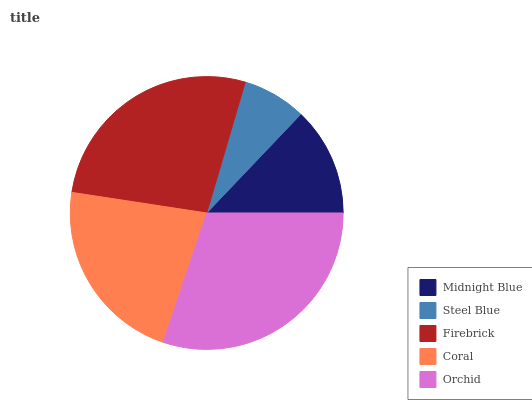Is Steel Blue the minimum?
Answer yes or no. Yes. Is Orchid the maximum?
Answer yes or no. Yes. Is Firebrick the minimum?
Answer yes or no. No. Is Firebrick the maximum?
Answer yes or no. No. Is Firebrick greater than Steel Blue?
Answer yes or no. Yes. Is Steel Blue less than Firebrick?
Answer yes or no. Yes. Is Steel Blue greater than Firebrick?
Answer yes or no. No. Is Firebrick less than Steel Blue?
Answer yes or no. No. Is Coral the high median?
Answer yes or no. Yes. Is Coral the low median?
Answer yes or no. Yes. Is Firebrick the high median?
Answer yes or no. No. Is Steel Blue the low median?
Answer yes or no. No. 